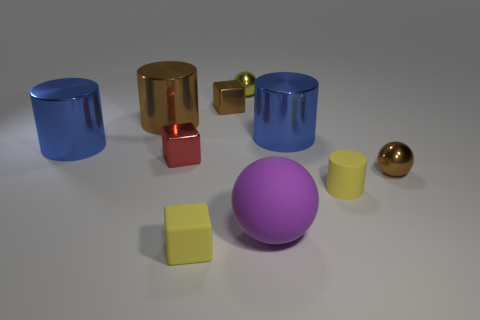How many objects are shiny objects that are behind the rubber sphere or purple balls?
Ensure brevity in your answer.  8. Are there an equal number of metal cubes that are in front of the brown metal cylinder and red objects?
Your answer should be compact. Yes. Is the color of the rubber cylinder the same as the rubber block?
Your response must be concise. Yes. There is a thing that is in front of the small yellow matte cylinder and left of the purple object; what is its color?
Provide a succinct answer. Yellow. How many cylinders are tiny yellow matte objects or yellow objects?
Your answer should be very brief. 1. Are there fewer yellow metallic balls that are behind the yellow metallic thing than rubber blocks?
Provide a succinct answer. Yes. There is a tiny yellow thing that is the same material as the small red thing; what shape is it?
Offer a very short reply. Sphere. What number of tiny cylinders are the same color as the large matte sphere?
Your response must be concise. 0. How many objects are yellow matte cubes or small green rubber cylinders?
Provide a short and direct response. 1. What material is the cube that is right of the cube that is in front of the tiny yellow matte cylinder made of?
Keep it short and to the point. Metal. 